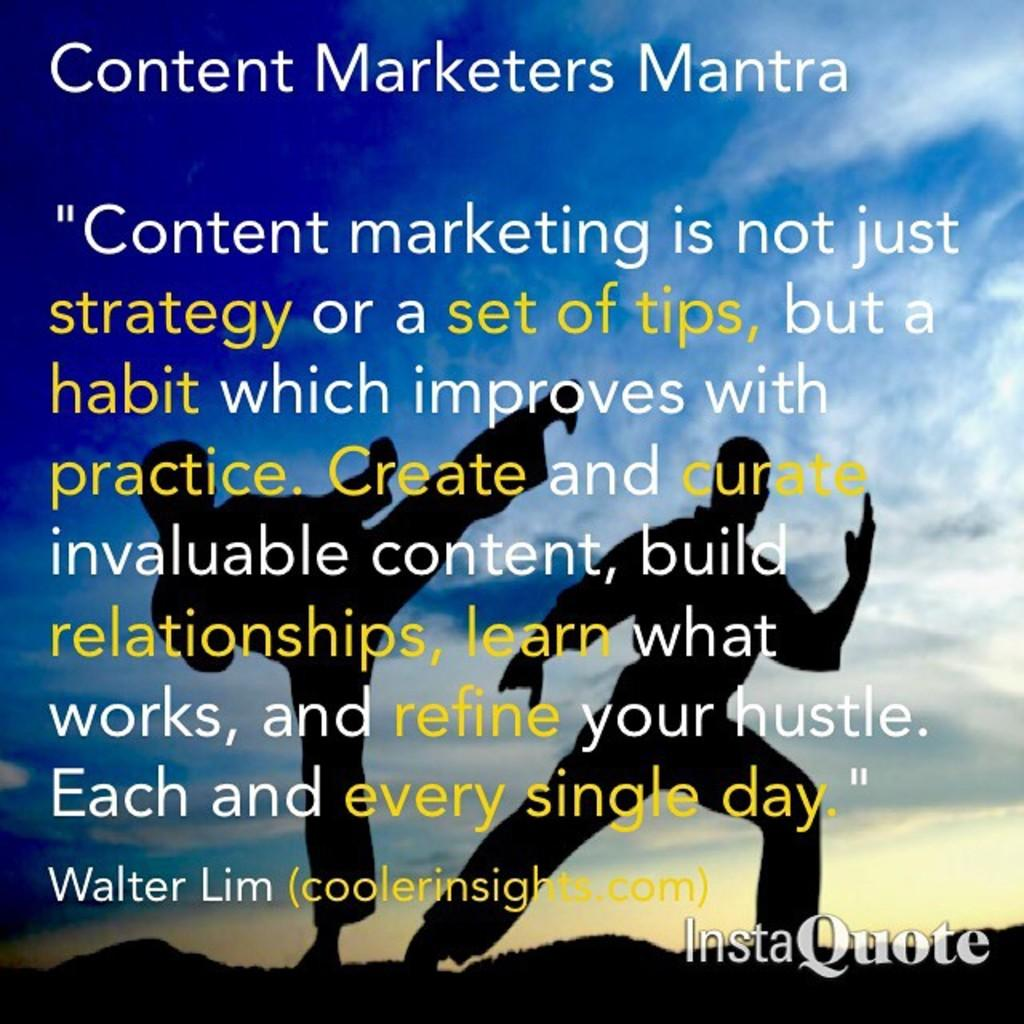<image>
Offer a succinct explanation of the picture presented. Instaquote of Content Marketers Mantra with a coolerinsights.com website 